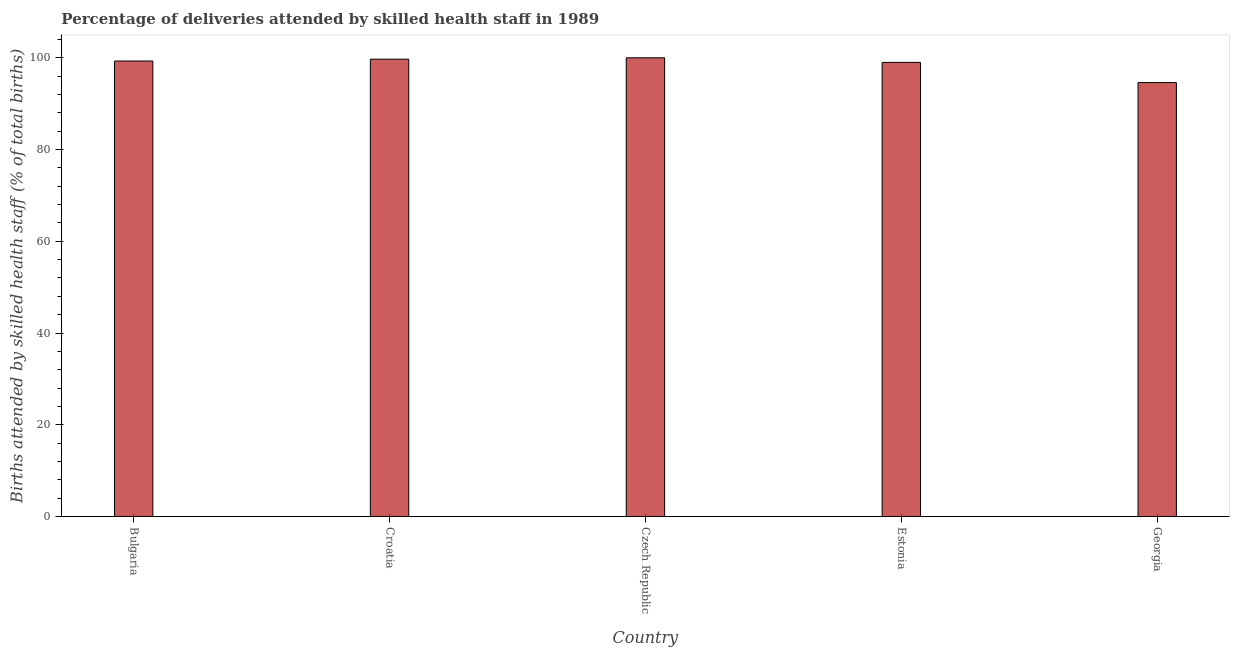Does the graph contain any zero values?
Make the answer very short. No. What is the title of the graph?
Offer a very short reply. Percentage of deliveries attended by skilled health staff in 1989. What is the label or title of the X-axis?
Your answer should be compact. Country. What is the label or title of the Y-axis?
Provide a succinct answer. Births attended by skilled health staff (% of total births). What is the number of births attended by skilled health staff in Czech Republic?
Your answer should be very brief. 100. Across all countries, what is the minimum number of births attended by skilled health staff?
Offer a terse response. 94.6. In which country was the number of births attended by skilled health staff maximum?
Your answer should be compact. Czech Republic. In which country was the number of births attended by skilled health staff minimum?
Offer a very short reply. Georgia. What is the sum of the number of births attended by skilled health staff?
Make the answer very short. 492.6. What is the difference between the number of births attended by skilled health staff in Croatia and Czech Republic?
Offer a terse response. -0.3. What is the average number of births attended by skilled health staff per country?
Provide a succinct answer. 98.52. What is the median number of births attended by skilled health staff?
Your answer should be very brief. 99.3. In how many countries, is the number of births attended by skilled health staff greater than 40 %?
Provide a succinct answer. 5. Is the difference between the number of births attended by skilled health staff in Czech Republic and Georgia greater than the difference between any two countries?
Keep it short and to the point. Yes. What is the difference between the highest and the second highest number of births attended by skilled health staff?
Offer a very short reply. 0.3. What is the Births attended by skilled health staff (% of total births) of Bulgaria?
Offer a very short reply. 99.3. What is the Births attended by skilled health staff (% of total births) of Croatia?
Keep it short and to the point. 99.7. What is the Births attended by skilled health staff (% of total births) in Estonia?
Make the answer very short. 99. What is the Births attended by skilled health staff (% of total births) in Georgia?
Your answer should be very brief. 94.6. What is the difference between the Births attended by skilled health staff (% of total births) in Bulgaria and Croatia?
Offer a terse response. -0.4. What is the difference between the Births attended by skilled health staff (% of total births) in Bulgaria and Czech Republic?
Your response must be concise. -0.7. What is the difference between the Births attended by skilled health staff (% of total births) in Bulgaria and Georgia?
Your answer should be compact. 4.7. What is the difference between the Births attended by skilled health staff (% of total births) in Czech Republic and Estonia?
Keep it short and to the point. 1. What is the difference between the Births attended by skilled health staff (% of total births) in Czech Republic and Georgia?
Give a very brief answer. 5.4. What is the ratio of the Births attended by skilled health staff (% of total births) in Bulgaria to that in Georgia?
Your answer should be compact. 1.05. What is the ratio of the Births attended by skilled health staff (% of total births) in Croatia to that in Estonia?
Your answer should be compact. 1.01. What is the ratio of the Births attended by skilled health staff (% of total births) in Croatia to that in Georgia?
Your answer should be compact. 1.05. What is the ratio of the Births attended by skilled health staff (% of total births) in Czech Republic to that in Estonia?
Give a very brief answer. 1.01. What is the ratio of the Births attended by skilled health staff (% of total births) in Czech Republic to that in Georgia?
Your answer should be compact. 1.06. What is the ratio of the Births attended by skilled health staff (% of total births) in Estonia to that in Georgia?
Keep it short and to the point. 1.05. 